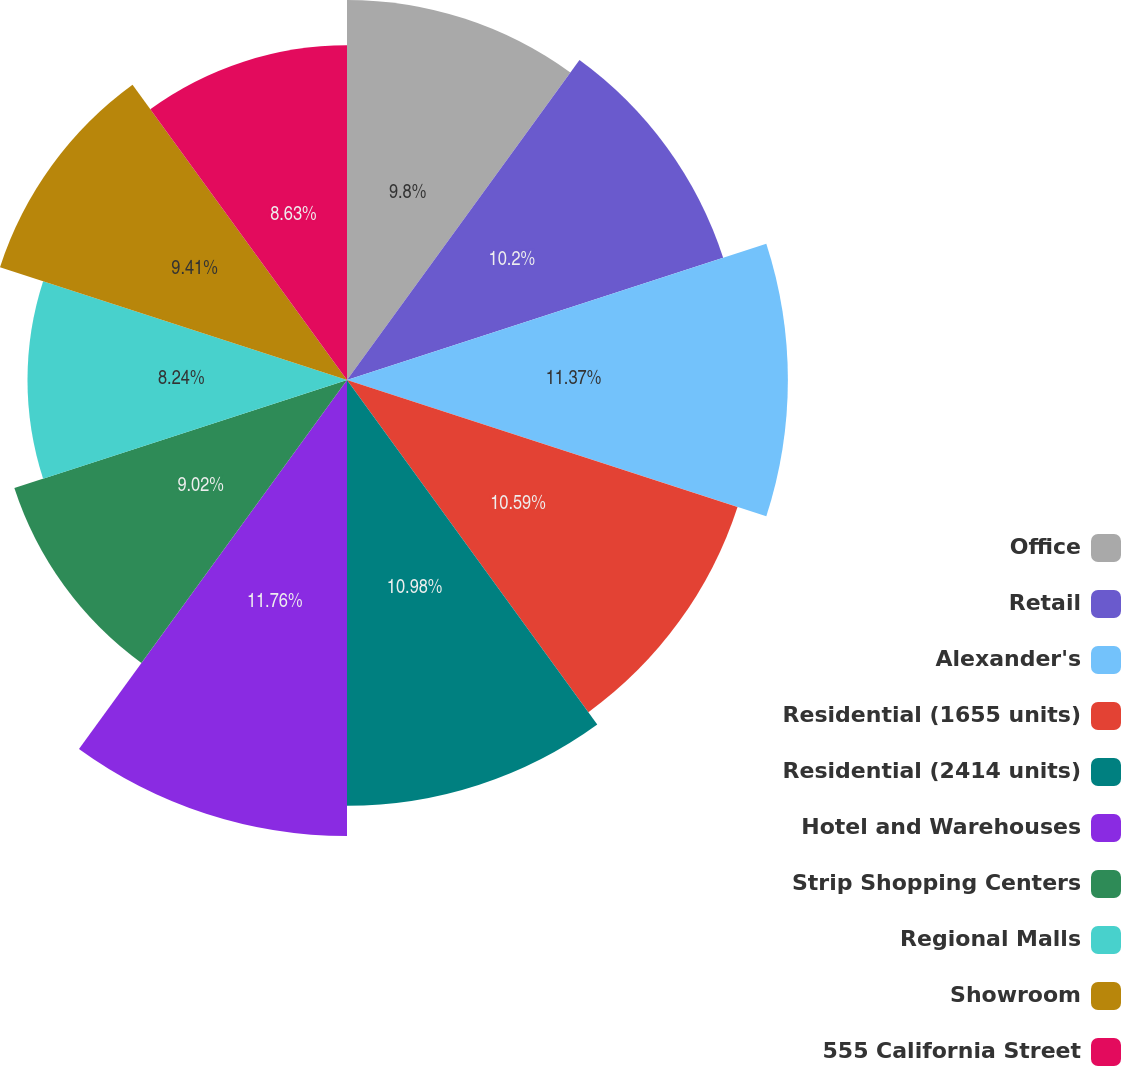<chart> <loc_0><loc_0><loc_500><loc_500><pie_chart><fcel>Office<fcel>Retail<fcel>Alexander's<fcel>Residential (1655 units)<fcel>Residential (2414 units)<fcel>Hotel and Warehouses<fcel>Strip Shopping Centers<fcel>Regional Malls<fcel>Showroom<fcel>555 California Street<nl><fcel>9.8%<fcel>10.2%<fcel>11.37%<fcel>10.59%<fcel>10.98%<fcel>11.76%<fcel>9.02%<fcel>8.24%<fcel>9.41%<fcel>8.63%<nl></chart> 